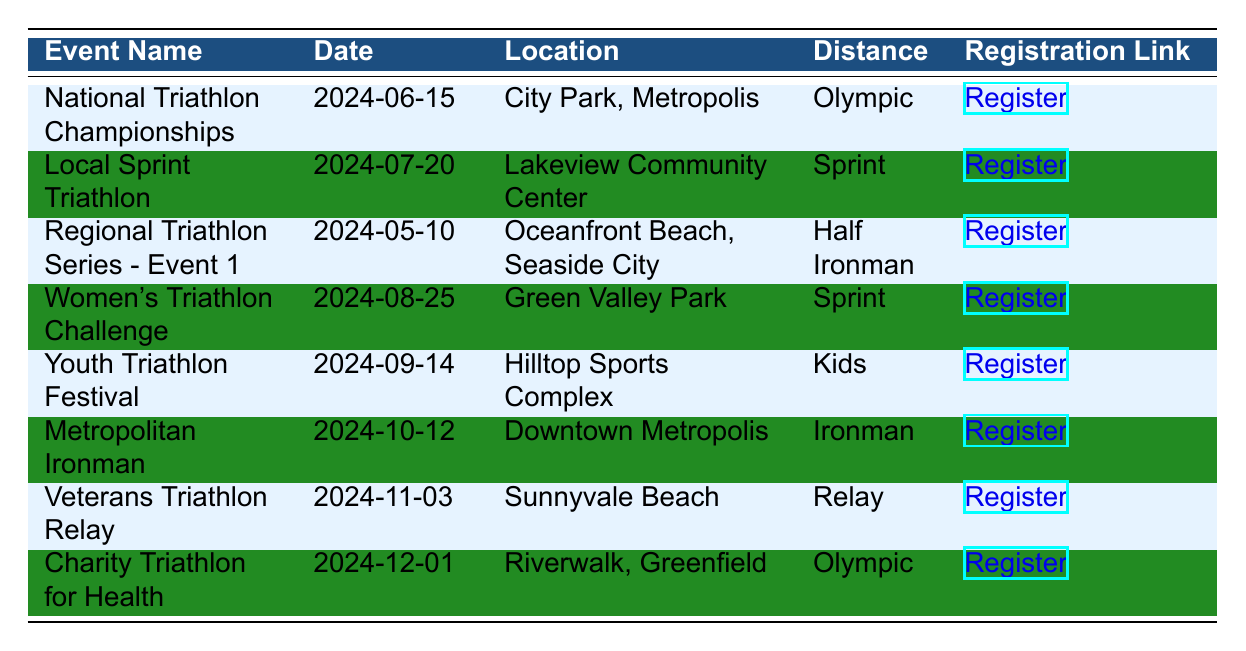What date is the National Triathlon Championships scheduled for? Looking at the event name "National Triathlon Championships," the corresponding date in the same row is "2024-06-15."
Answer: 2024-06-15 Where will the Local Sprint Triathlon take place? The "Local Sprint Triathlon" has the location listed as "Lakeview Community Center" in its respective row.
Answer: Lakeview Community Center Is there a triathlon event specifically for youth? The table includes the "Youth Triathlon Festival," which is designated for kids based on the distance category listed as "Kids." Therefore, there is an event specifically for youth.
Answer: Yes How many events are scheduled for the month of October? The table indicates two events in October: "Metropolitan Ironman" on "2024-10-12" and "Veterans Triathlon Relay" on "2024-11-03." Hence, counting these entries, the total number of events in October is one.
Answer: 1 Which event has the longest distance, and what is it? From the distance categories provided: "Olympic," "Sprint," "Half Ironman," "Kids," "Ironman," "Relay," and "Olympic," 'Ironman' represents the longest distance. The "Metropolitan Ironman" event corresponds to this distance.
Answer: Metropolitan Ironman, Ironman How many Olympic distance triathlon events are there in the schedule? The events considered Olympic distance are "National Triathlon Championships" and "Charity Triathlon for Health." Therefore, summing these entries gives a total of 2 Olympic events.
Answer: 2 What is the location of the Women’s Triathlon Challenge? The "Women’s Triathlon Challenge" is located at "Green Valley Park" as per the information in its row.
Answer: Green Valley Park Are there any triathlon events taking place in December? The event scheduled in December is the "Charity Triathlon for Health" on "2024-12-01," indicating that there is indeed an event in December.
Answer: Yes What is the distance of the Regional Triathlon Series - Event 1? The "Regional Triathlon Series - Event 1" is categorized under the distance as "Half Ironman" in the table, which can be directly referenced.
Answer: Half Ironman 